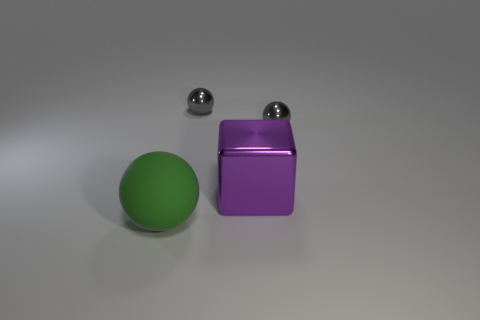Subtract all metal spheres. How many spheres are left? 1 Add 3 large metal blocks. How many objects exist? 7 Subtract all purple cubes. How many gray balls are left? 2 Subtract all green spheres. How many spheres are left? 2 Subtract 2 balls. How many balls are left? 1 Add 4 big yellow rubber cylinders. How many big yellow rubber cylinders exist? 4 Subtract 0 red cylinders. How many objects are left? 4 Subtract all balls. How many objects are left? 1 Subtract all yellow balls. Subtract all brown blocks. How many balls are left? 3 Subtract all metallic objects. Subtract all big purple cubes. How many objects are left? 0 